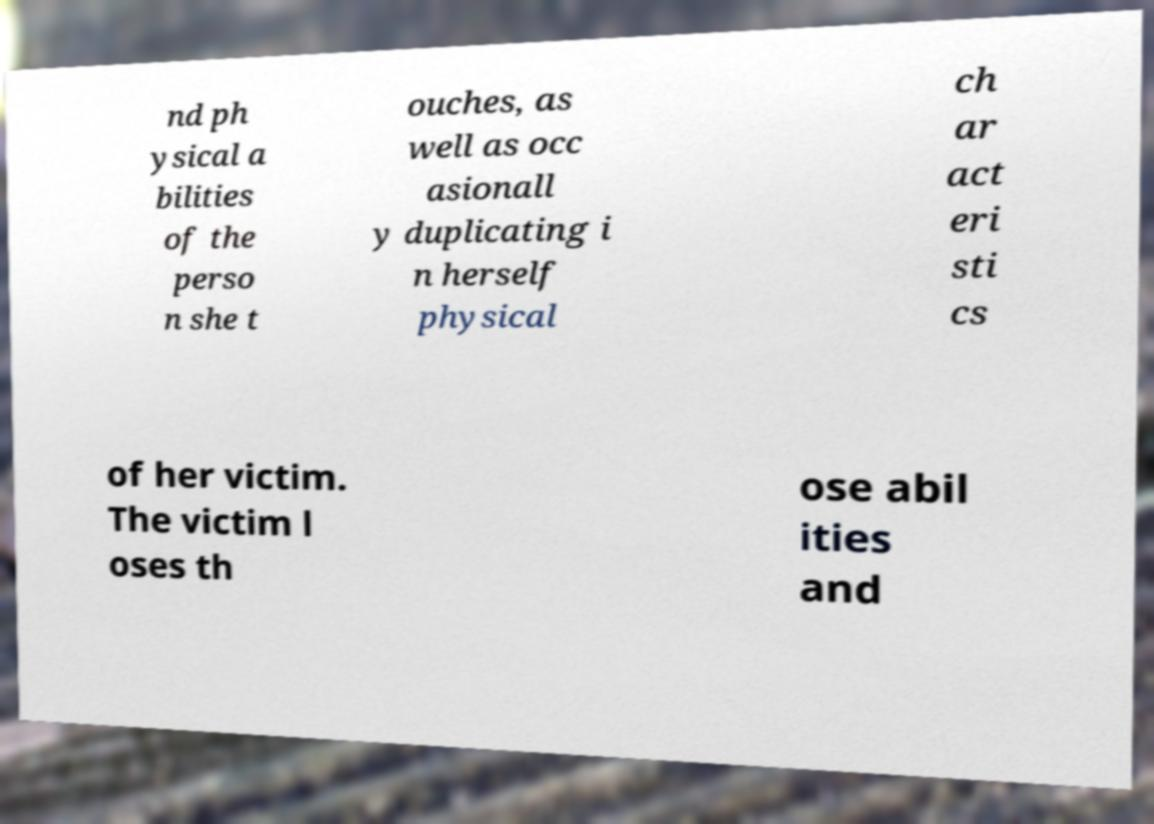Can you accurately transcribe the text from the provided image for me? nd ph ysical a bilities of the perso n she t ouches, as well as occ asionall y duplicating i n herself physical ch ar act eri sti cs of her victim. The victim l oses th ose abil ities and 